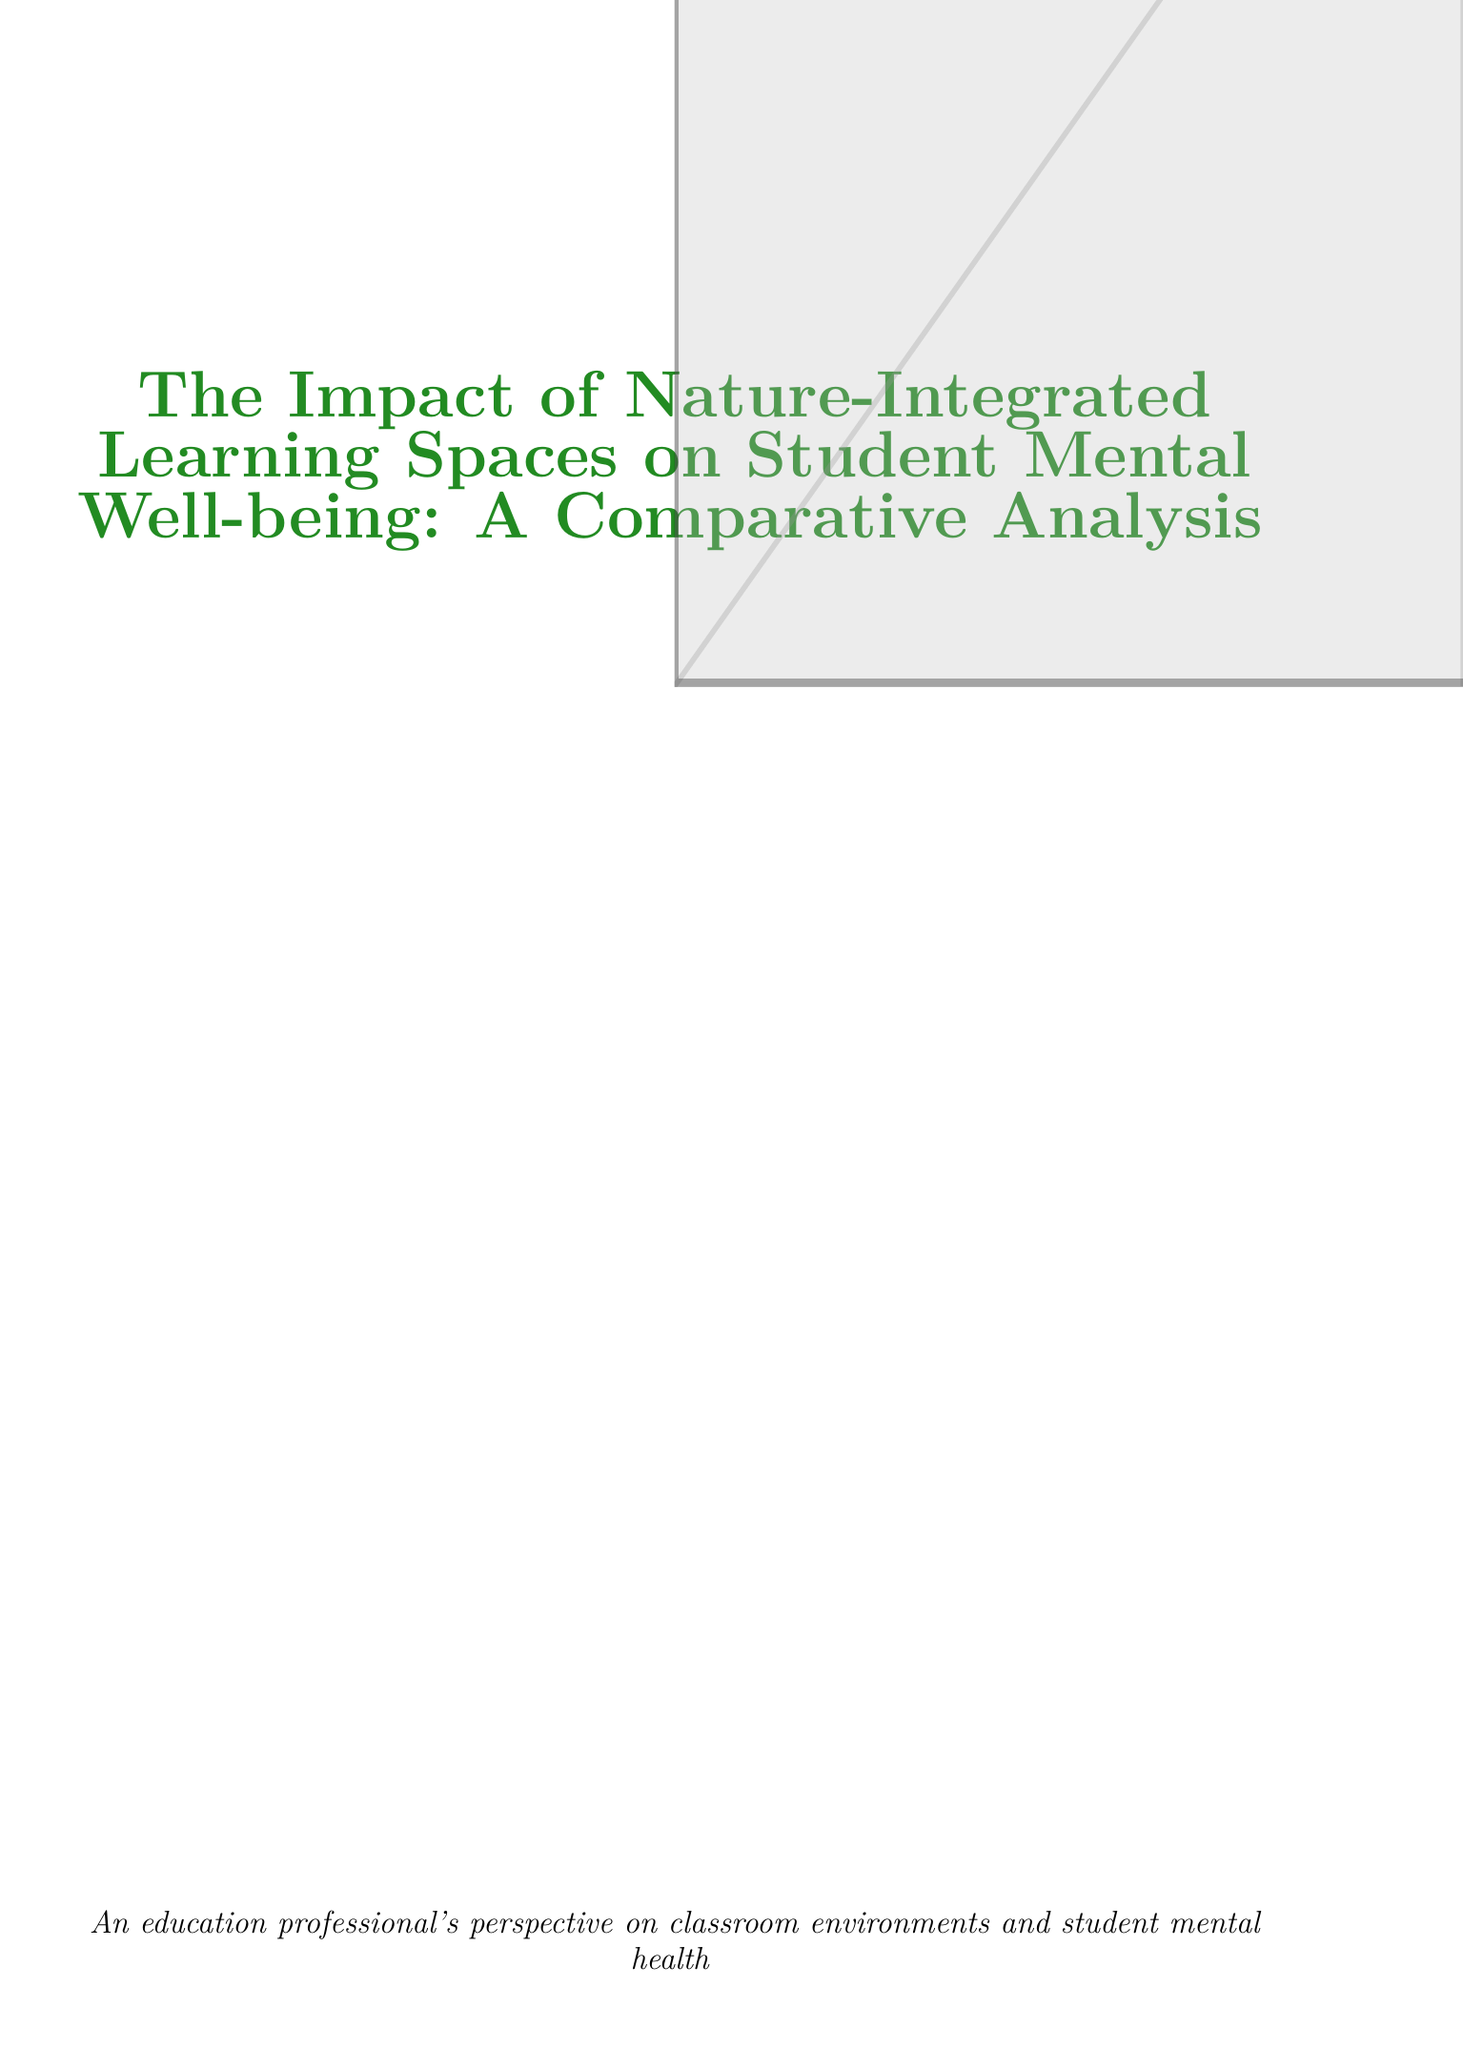what is the average stress level in traditional classrooms? The document states the average stress level in traditional classrooms is 6.8 out of 10.
Answer: 6.8/10 what percentage of students in nature-integrated spaces reported moderate to severe anxiety? The report indicates that 27% of students in nature-integrated spaces reported moderate to severe anxiety.
Answer: 27% what is the mean GPA for students in nature-integrated learning spaces? According to the document, the mean GPA for students in nature-integrated spaces is 3.4 out of 4.0.
Answer: 3.4/4.0 what improvement in average GPA was observed in nature-integrated classrooms? The report shows a 9.7% increase in average GPA due to nature-integrated classrooms.
Answer: 9.7% who stated that nature integration supports student mental health? Dr. Emily Chen from Harvard Graduate School of Education made this statement.
Answer: Dr. Emily Chen what was one implementation strategy used at Green Valley High School? The school converted 50% of classrooms to nature-integrated spaces as an implementation strategy.
Answer: Converted 50% of classrooms what challenge is mentioned regarding nature-integrated classrooms? The document lists initial costs of redesigning classrooms as a challenge.
Answer: Initial costs of redesigning classrooms how long was the study conducted? The study was conducted over a 2-year period from 2019 to 2021.
Answer: 2 years what is one recommendation for teachers regarding nature-based learning spaces? The report recommends professional development for teachers on utilizing nature-based learning spaces.
Answer: Professional development for teachers 